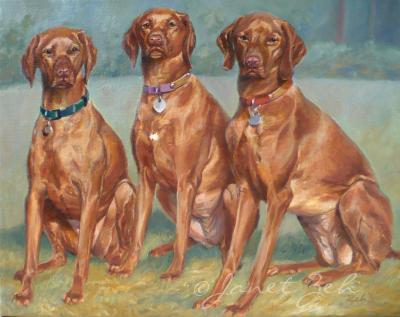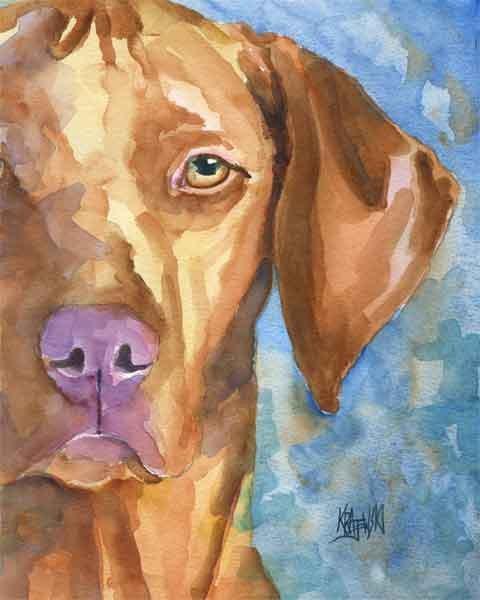The first image is the image on the left, the second image is the image on the right. For the images shown, is this caption "There are more dogs in the image on the right." true? Answer yes or no. No. The first image is the image on the left, the second image is the image on the right. Analyze the images presented: Is the assertion "There are three dog in a row with different color collars on." valid? Answer yes or no. Yes. 